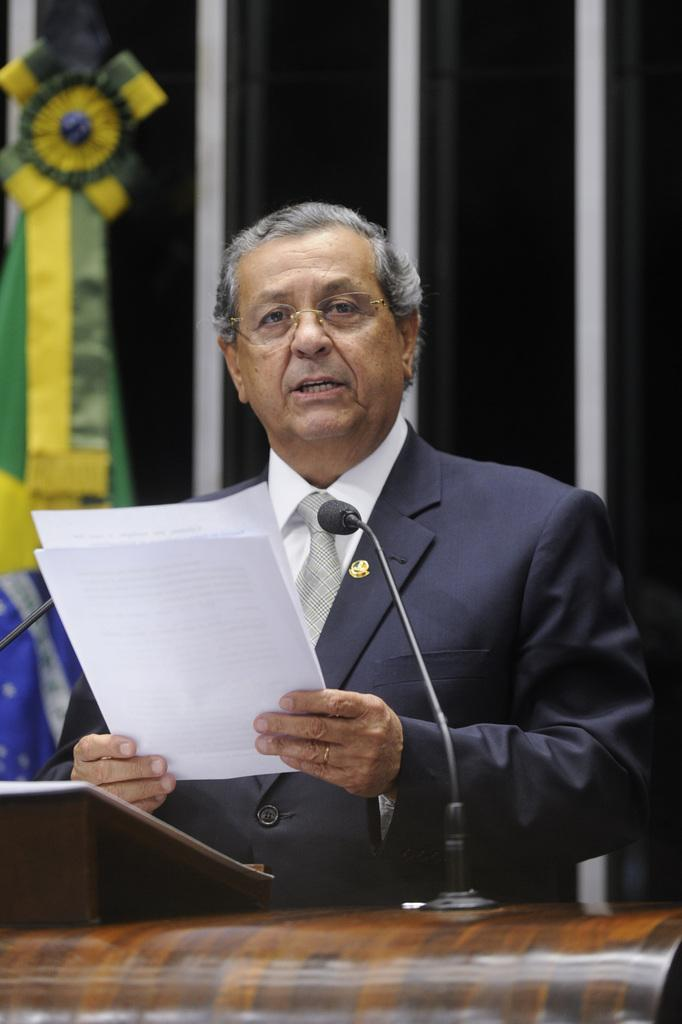What is the person in the image doing? The person is standing at a desk in the image. What items can be seen on the desk? The person has papers on the desk. What is visible in the background of the image? There is a flag and a wall in the background of the image. What type of harbor can be seen in the image? There is no harbor present in the image; it features a person standing at a desk with papers and a background that includes a flag and a wall. 